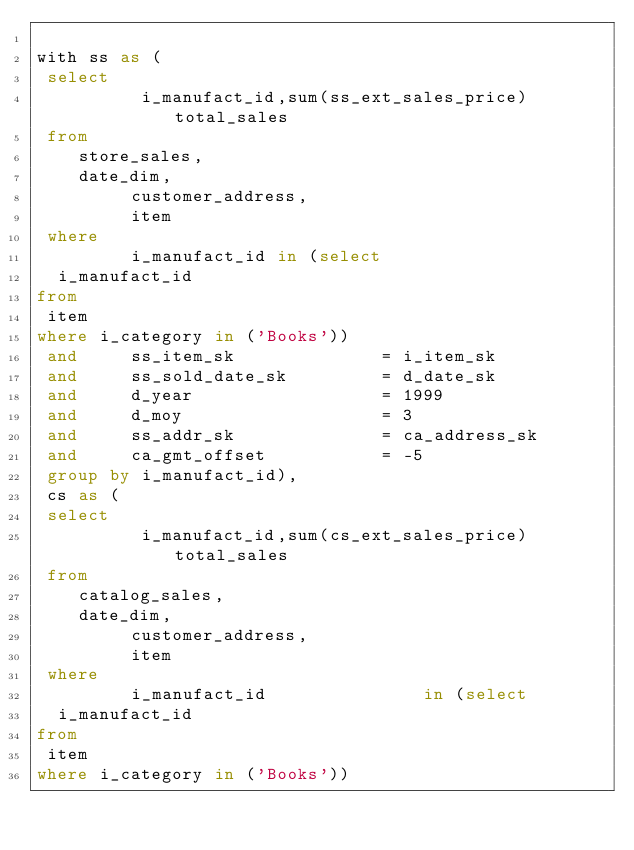Convert code to text. <code><loc_0><loc_0><loc_500><loc_500><_SQL_>
with ss as (
 select
          i_manufact_id,sum(ss_ext_sales_price) total_sales
 from
 	store_sales,
 	date_dim,
         customer_address,
         item
 where
         i_manufact_id in (select
  i_manufact_id
from
 item
where i_category in ('Books'))
 and     ss_item_sk              = i_item_sk
 and     ss_sold_date_sk         = d_date_sk
 and     d_year                  = 1999
 and     d_moy                   = 3
 and     ss_addr_sk              = ca_address_sk
 and     ca_gmt_offset           = -5 
 group by i_manufact_id),
 cs as (
 select
          i_manufact_id,sum(cs_ext_sales_price) total_sales
 from
 	catalog_sales,
 	date_dim,
         customer_address,
         item
 where
         i_manufact_id               in (select
  i_manufact_id
from
 item
where i_category in ('Books'))</code> 